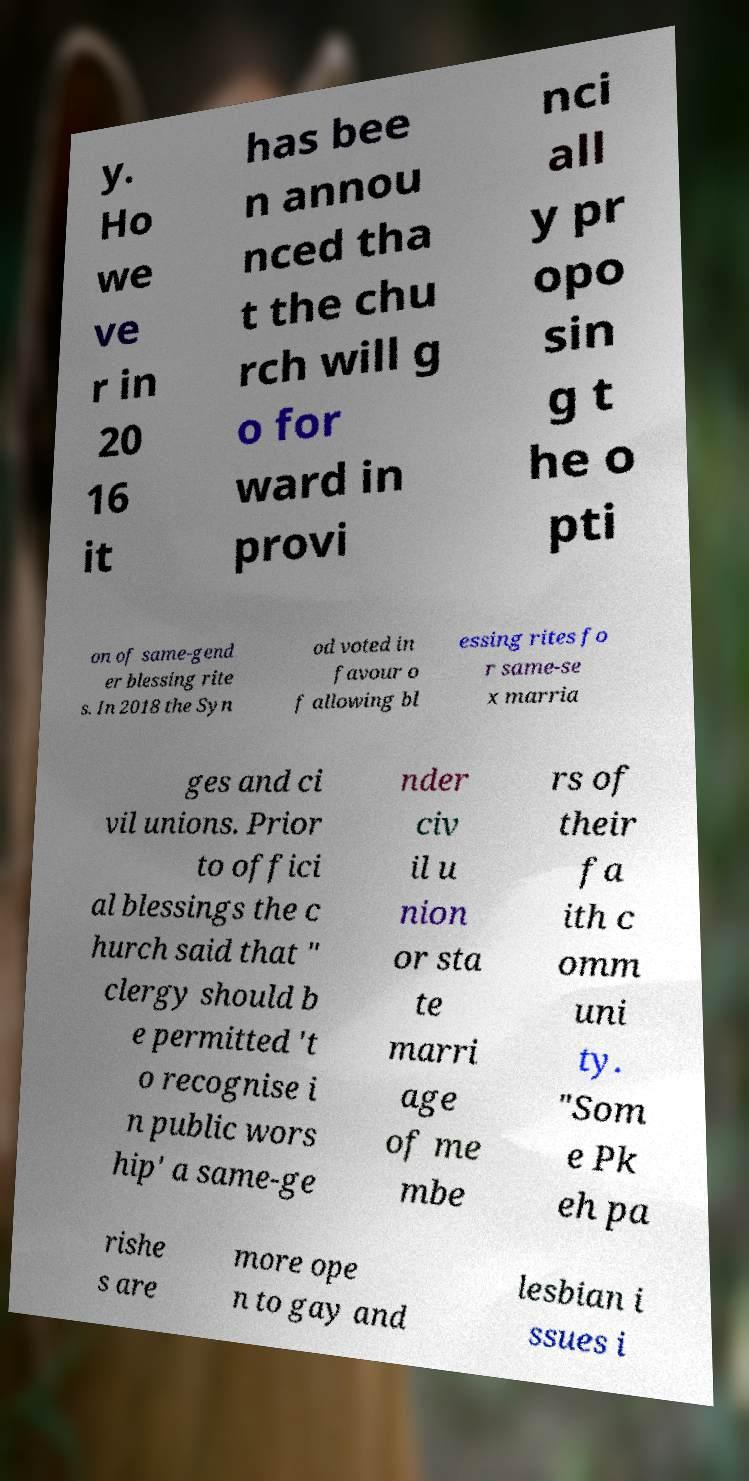For documentation purposes, I need the text within this image transcribed. Could you provide that? y. Ho we ve r in 20 16 it has bee n annou nced tha t the chu rch will g o for ward in provi nci all y pr opo sin g t he o pti on of same-gend er blessing rite s. In 2018 the Syn od voted in favour o f allowing bl essing rites fo r same-se x marria ges and ci vil unions. Prior to offici al blessings the c hurch said that " clergy should b e permitted 't o recognise i n public wors hip' a same-ge nder civ il u nion or sta te marri age of me mbe rs of their fa ith c omm uni ty. "Som e Pk eh pa rishe s are more ope n to gay and lesbian i ssues i 